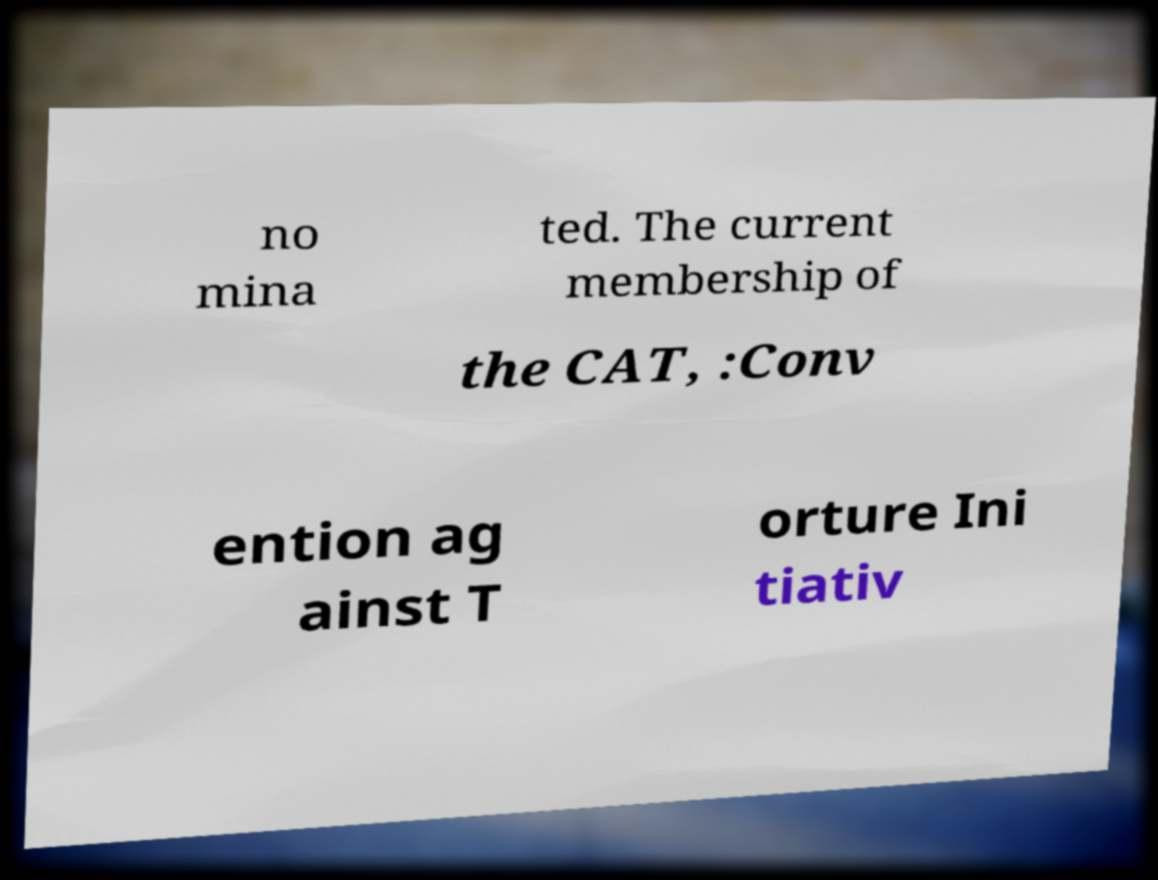I need the written content from this picture converted into text. Can you do that? no mina ted. The current membership of the CAT, :Conv ention ag ainst T orture Ini tiativ 